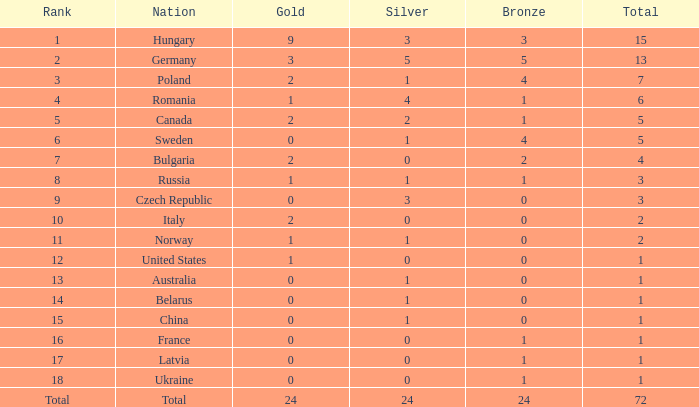What is the average total when the gold is 0 and the rank is 6? 5.0. 